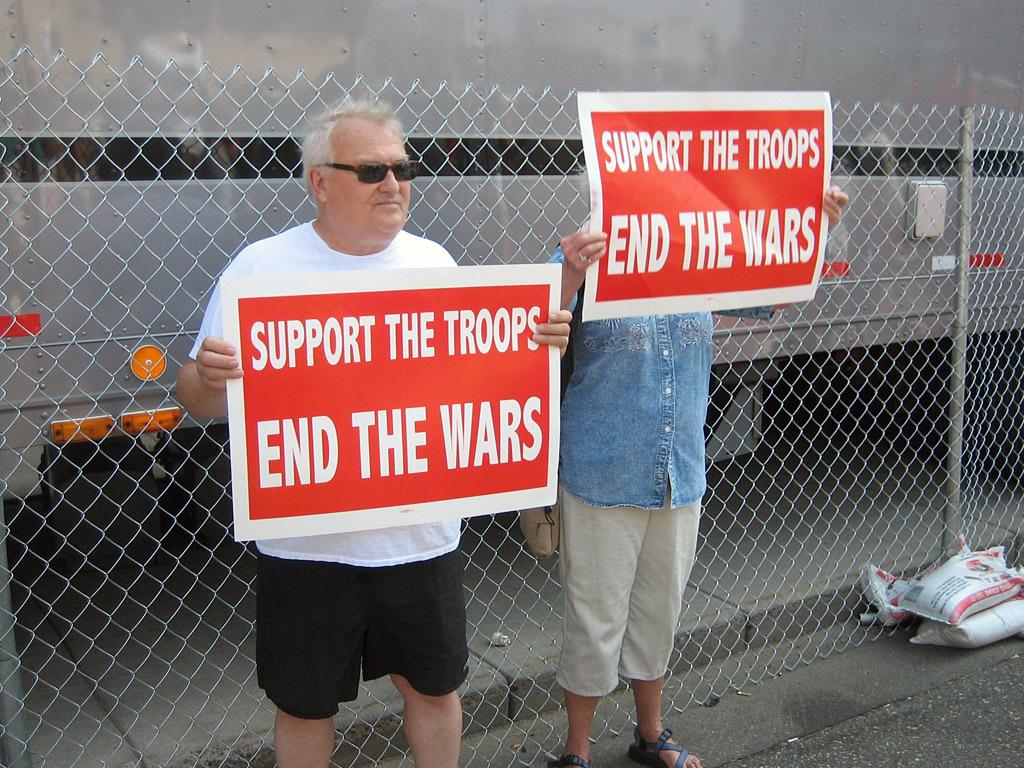How many people are in the image? There are two people standing in the image. What are the people wearing? Both people are wearing clothes. Can you describe any specific accessory one of the people is wearing? One person is wearing goggles. What can be seen on the walls in the image? There are posters in the image. What type of structure is present in the image? There is a fence in the image. What is a possible path for walking in the image? There is a footpath in the image. What object is visible in the image? There is an object in the image. What is the tall, vertical structure in the image? There is a pole in the image. What type of flowers can be seen growing near the footpath in the image? There are no flowers visible in the image; the focus is on the people, posters, fence, object, and pole. 